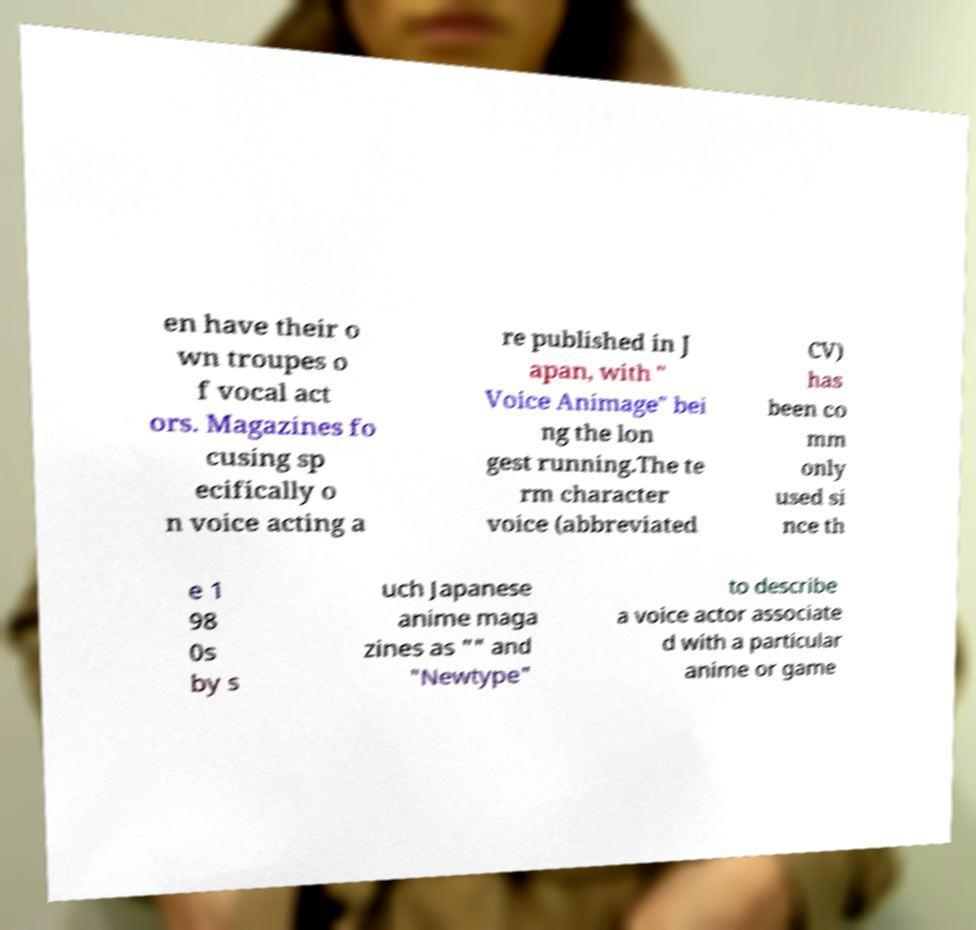Could you extract and type out the text from this image? en have their o wn troupes o f vocal act ors. Magazines fo cusing sp ecifically o n voice acting a re published in J apan, with " Voice Animage" bei ng the lon gest running.The te rm character voice (abbreviated CV) has been co mm only used si nce th e 1 98 0s by s uch Japanese anime maga zines as "" and "Newtype" to describe a voice actor associate d with a particular anime or game 